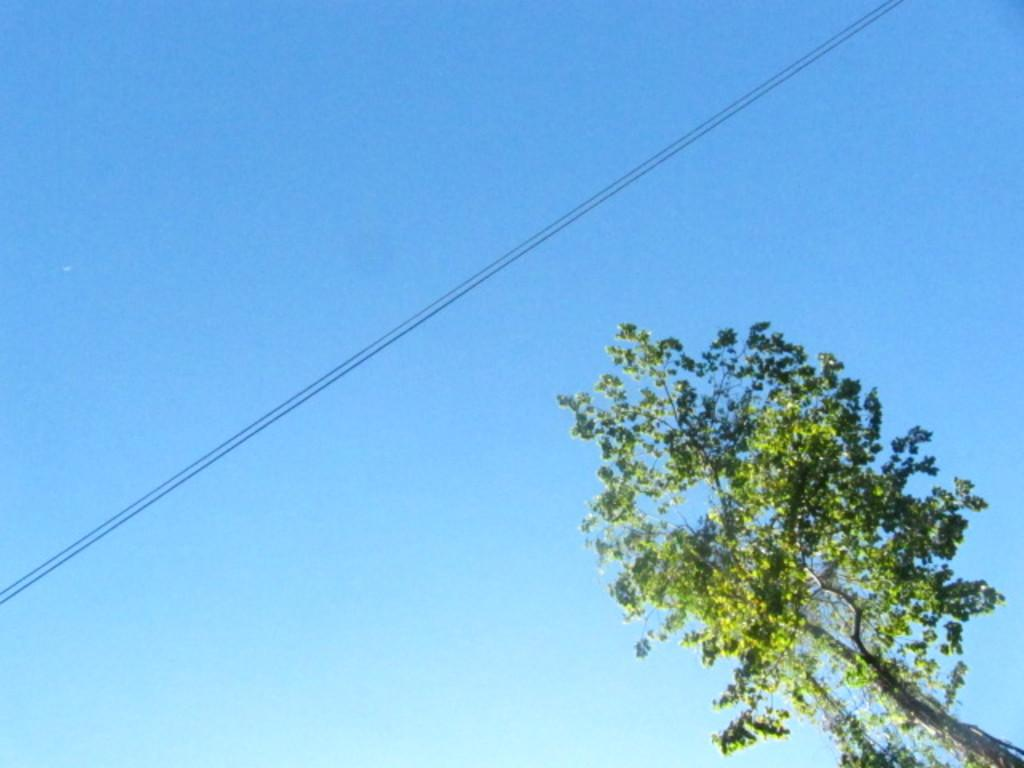What type of vegetation is on the right side of the image? There is a tree on the right side of the image. What can be seen in the center of the image? There is a wire in the center of the image. What is visible in the background of the image? The sky is visible in the background of the image. Is there a war taking place in the image? No, there is no indication of a war or any conflict in the image. Can you see a bridge in the image? No, there is no bridge present in the image. 